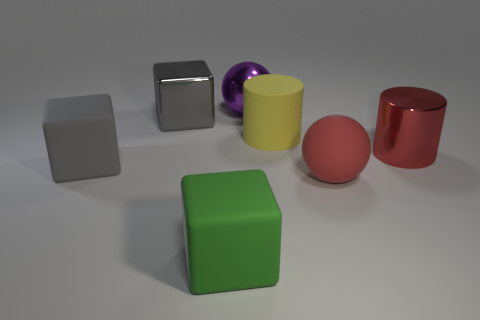Add 1 big cylinders. How many objects exist? 8 Subtract all blocks. How many objects are left? 4 Add 6 small brown matte spheres. How many small brown matte spheres exist? 6 Subtract 0 purple cubes. How many objects are left? 7 Subtract all matte spheres. Subtract all blocks. How many objects are left? 3 Add 7 matte blocks. How many matte blocks are left? 9 